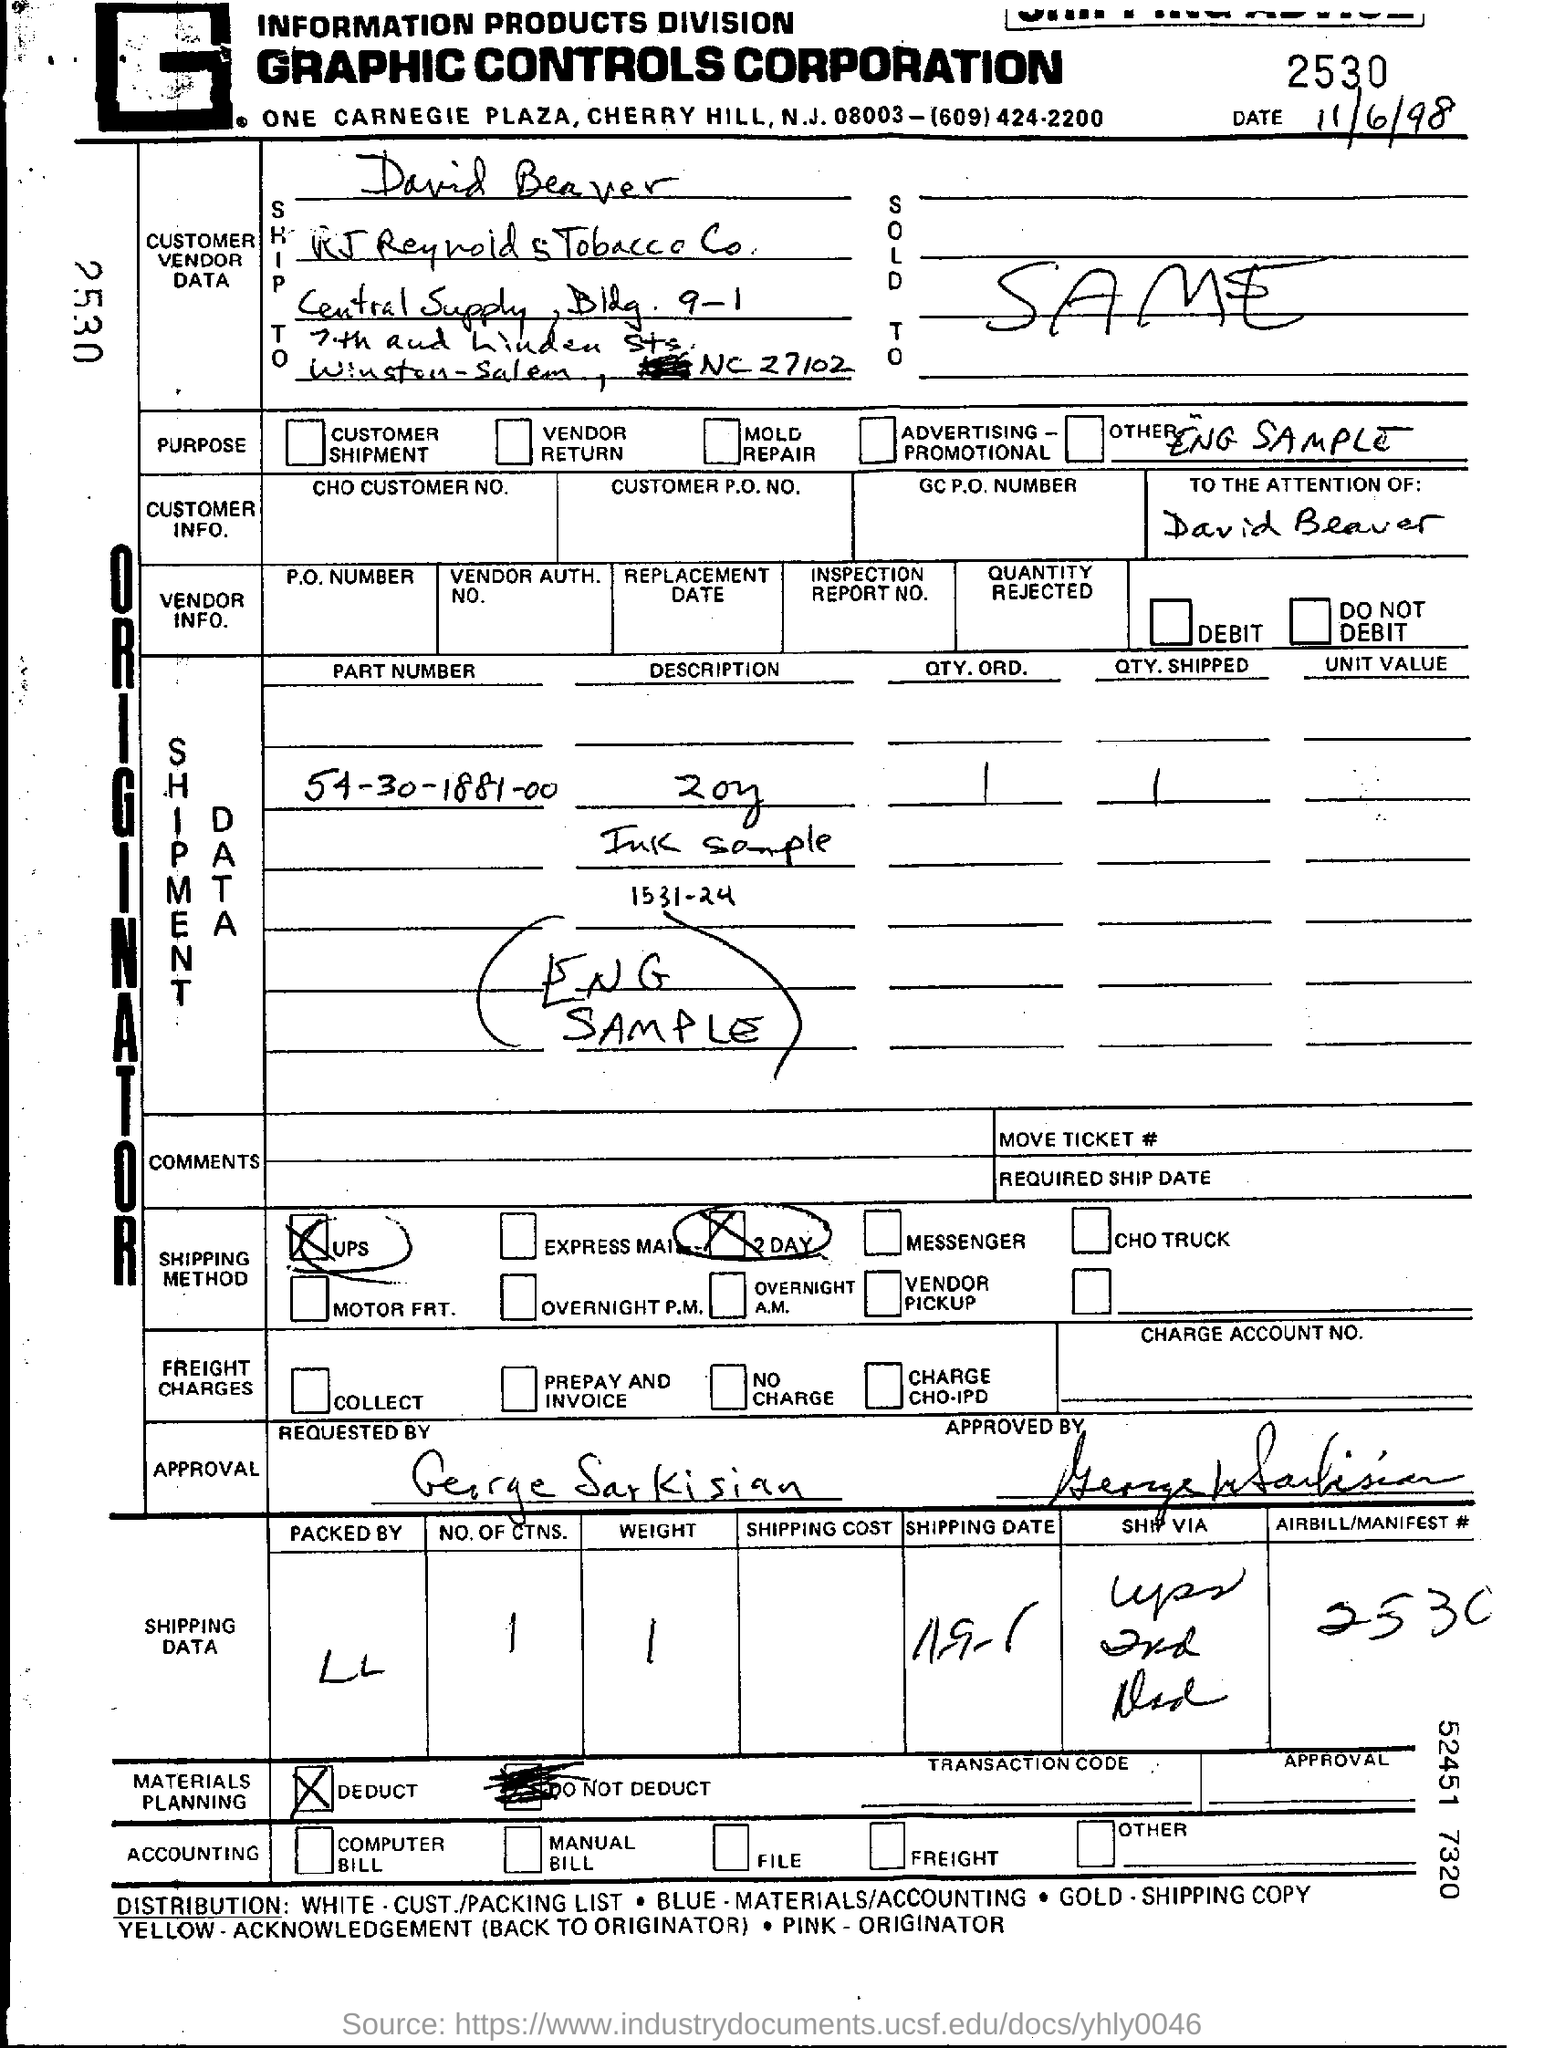What is the date mention in this document?
Keep it short and to the point. 11/6/98. 